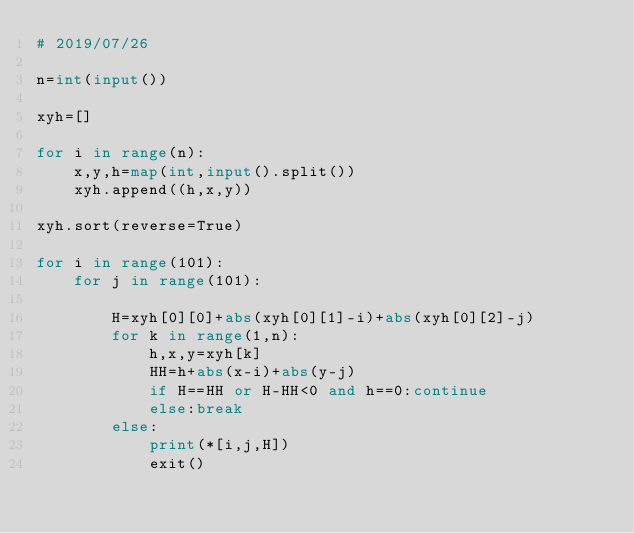<code> <loc_0><loc_0><loc_500><loc_500><_Python_># 2019/07/26

n=int(input())

xyh=[]

for i in range(n):
    x,y,h=map(int,input().split())
    xyh.append((h,x,y))

xyh.sort(reverse=True)

for i in range(101):
    for j in range(101):
        
        H=xyh[0][0]+abs(xyh[0][1]-i)+abs(xyh[0][2]-j)
        for k in range(1,n):
            h,x,y=xyh[k]
            HH=h+abs(x-i)+abs(y-j)
            if H==HH or H-HH<0 and h==0:continue
            else:break
        else:
            print(*[i,j,H])
            exit()</code> 